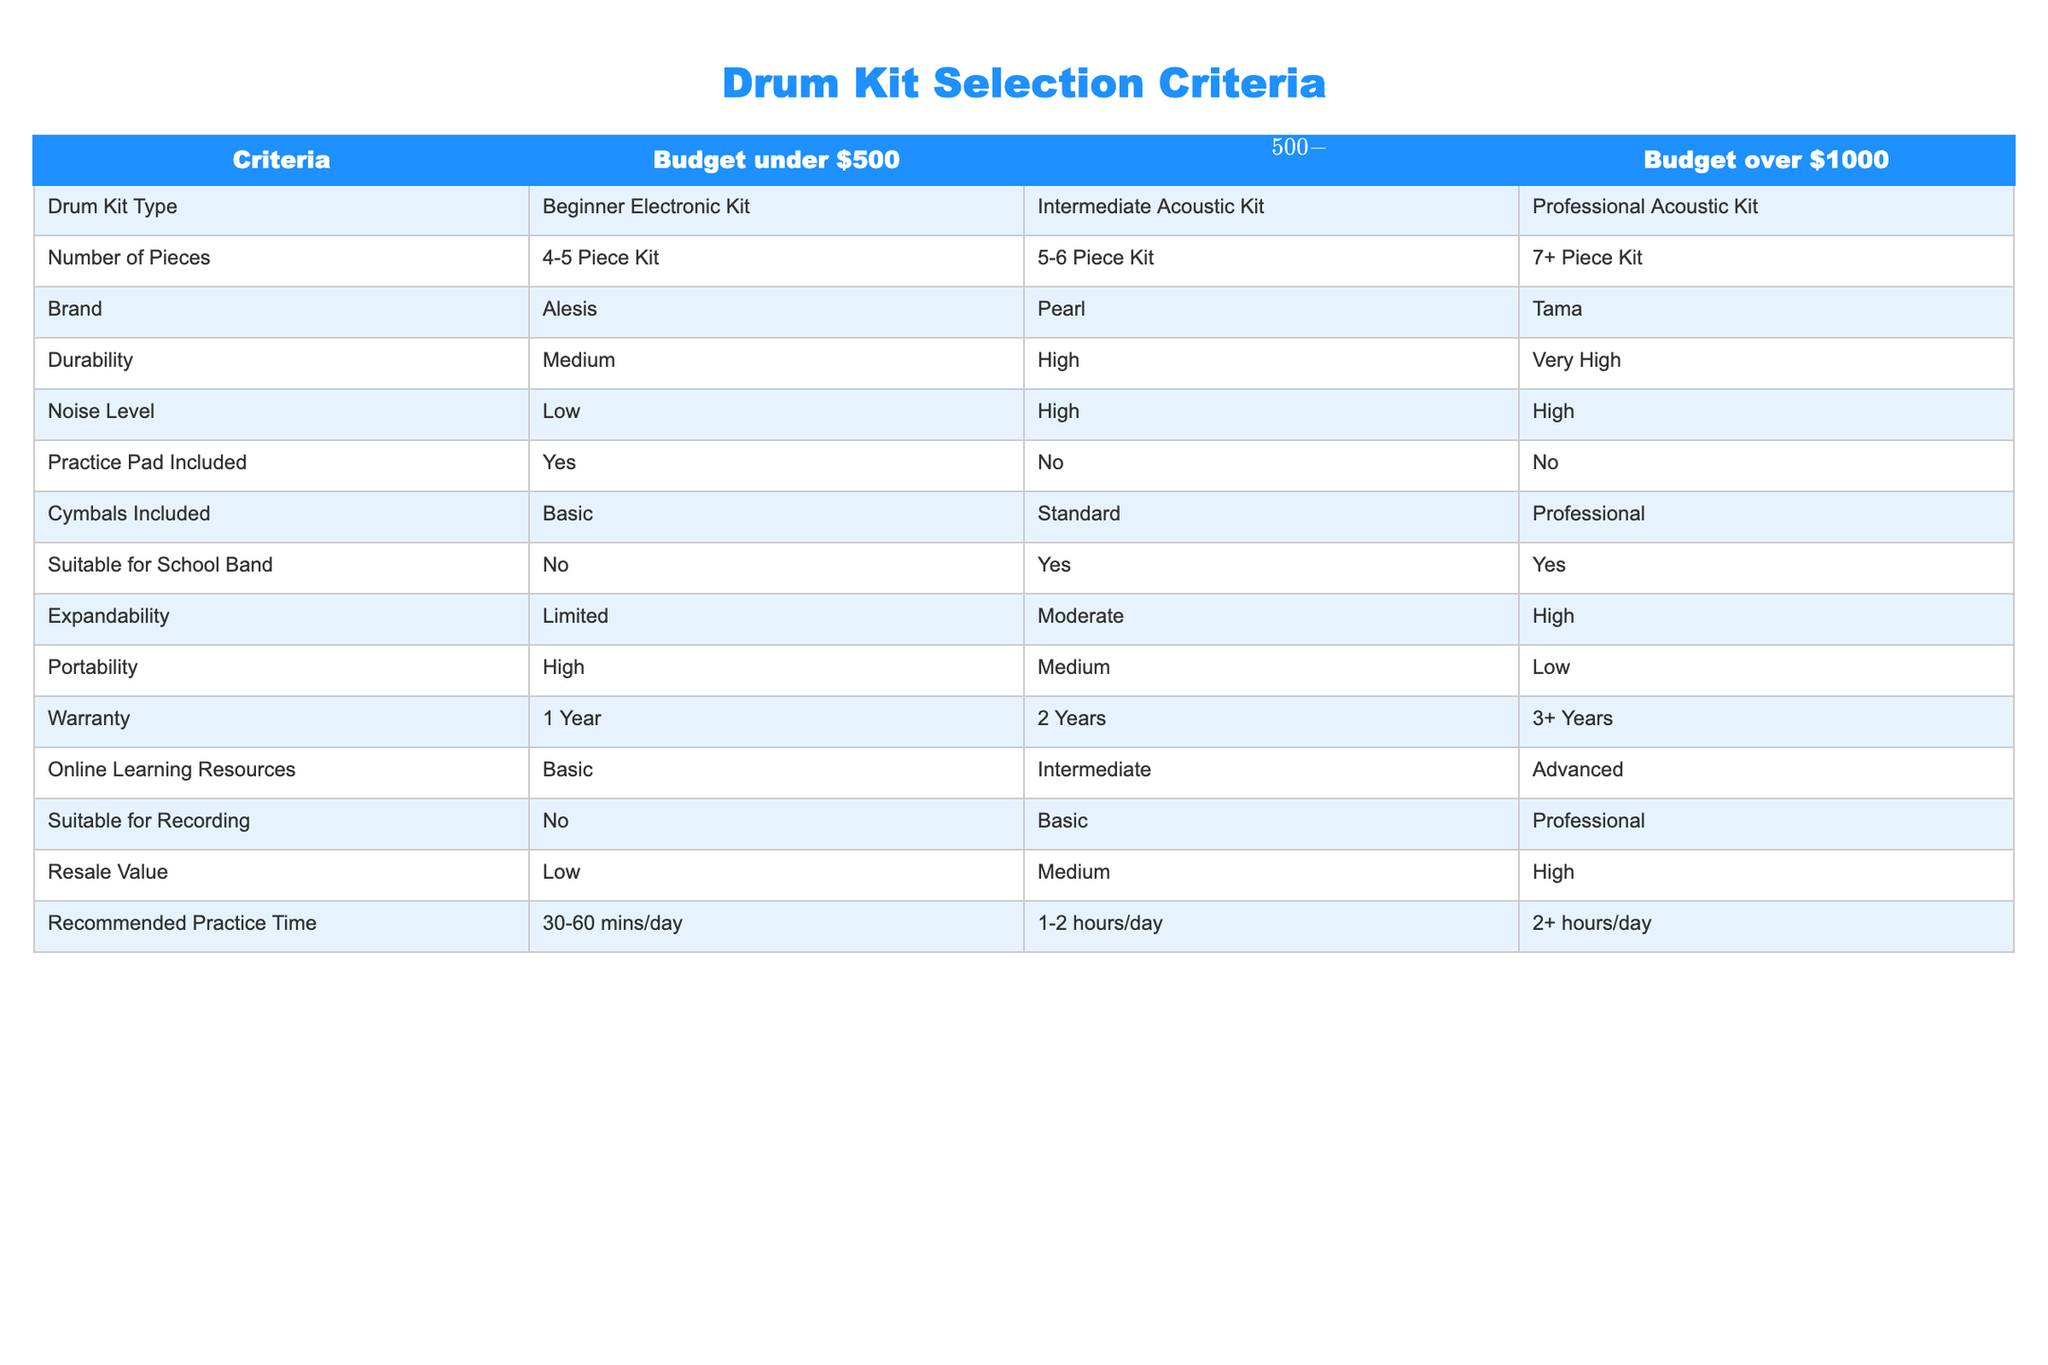What type of drum kit is recommended for a budget under $500? According to the table, the recommended drum kit type for a budget under $500 is a Beginner Electronic Kit.
Answer: Beginner Electronic Kit How many pieces does the Intermediate Acoustic Kit have? The table specifies that the Intermediate Acoustic Kit has a number of pieces in the range of 5-6.
Answer: 5-6 Piece Kit Is there a practice pad included with the Professional Acoustic Kit? Checking the table, the Professional Acoustic Kit does not include a practice pad.
Answer: No What is the highest warranty period available for a drum kit? By examining the table, the highest warranty period offered is 3+ years, which is associated with the Professional Acoustic Kit.
Answer: 3+ Years Which drum kit has a higher resale value: Intermediate Acoustic Kit or Beginner Electronic Kit? The resale value for the Intermediate Acoustic Kit is medium while for the Beginner Electronic Kit it is low. Thus, Medium (Intermediate) is higher than Low (Beginner).
Answer: Intermediate Acoustic Kit Which drum kit type is suitable for a school band according to the table? The table indicates that both the Intermediate Acoustic Kit and the Professional Acoustic Kit are suitable for a school band.
Answer: Intermediate and Professional Acoustic Kits What is the average number of recommended practice hours per day for drum kits within budget range of $500-$1000? The table shows that recommended practice time for the Intermediate Acoustic Kit is 1-2 hours per day. To find the average, we can consider the midpoint which is (1 + 2) / 2 = 1.5 hours as the average recommended practice time.
Answer: 1.5 hours/day How does the noise level of a Beginner Electronic Kit compare to that of a Professional Acoustic Kit? The noise level for the Beginner Electronic Kit is low, while for the Professional Acoustic Kit, it is high. Therefore, the Beginner Electronic Kit has a significantly lower noise level compared to the Professional Acoustic Kit.
Answer: Beginner Electronic Kit has lower noise level What are two benefits of choosing a 7+ piece kit over a 4-5 piece kit for beginners? Based on the table, two benefits include Higher expandability and Higher durability. The 7+ piece kit comes with high expandability, allowing more additions, and very high durability compared to the 4-5 piece kit which has medium expandability and medium durability.
Answer: High expandability and Very high durability 